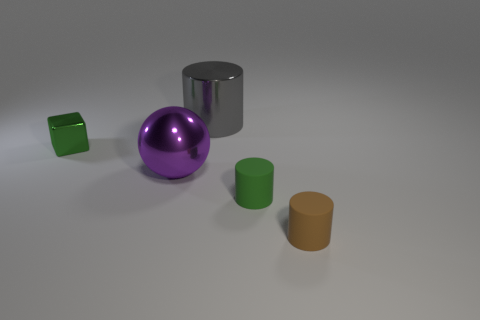Is the small cube the same color as the large cylinder?
Give a very brief answer. No. There is a rubber object that is left of the rubber thing right of the small green matte object; what number of tiny brown things are in front of it?
Ensure brevity in your answer.  1. What is the material of the tiny green thing that is to the right of the cylinder that is behind the large sphere?
Your answer should be very brief. Rubber. Are there any small matte objects that have the same shape as the tiny metallic object?
Provide a short and direct response. No. What color is the metallic thing that is the same size as the gray metallic cylinder?
Your answer should be very brief. Purple. What number of things are either big shiny objects that are right of the shiny ball or shiny things that are to the left of the large gray object?
Make the answer very short. 3. How many objects are small metal cubes or tiny rubber cylinders?
Give a very brief answer. 3. There is a cylinder that is both left of the small brown object and in front of the tiny metallic cube; how big is it?
Make the answer very short. Small. What number of red spheres are the same material as the large cylinder?
Provide a short and direct response. 0. There is another tiny cylinder that is made of the same material as the tiny green cylinder; what color is it?
Your answer should be compact. Brown. 